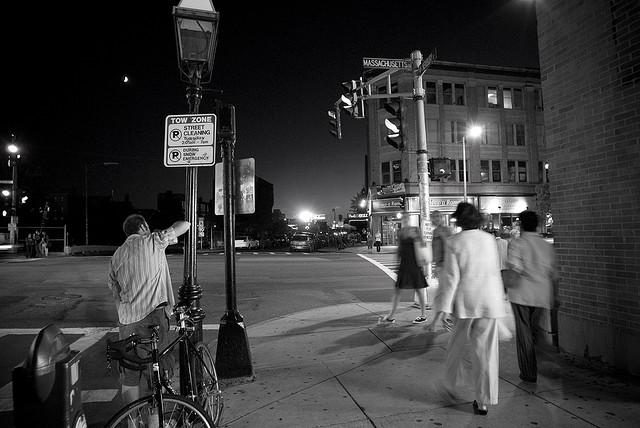What street name or intersection can be clearly seen on the corner?

Choices:
A) tow
B) massachusetts
C) perry
D) roma massachusetts 